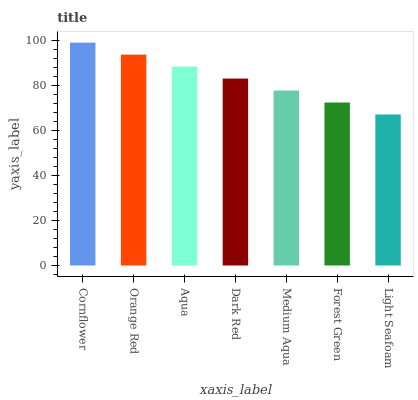Is Light Seafoam the minimum?
Answer yes or no. Yes. Is Cornflower the maximum?
Answer yes or no. Yes. Is Orange Red the minimum?
Answer yes or no. No. Is Orange Red the maximum?
Answer yes or no. No. Is Cornflower greater than Orange Red?
Answer yes or no. Yes. Is Orange Red less than Cornflower?
Answer yes or no. Yes. Is Orange Red greater than Cornflower?
Answer yes or no. No. Is Cornflower less than Orange Red?
Answer yes or no. No. Is Dark Red the high median?
Answer yes or no. Yes. Is Dark Red the low median?
Answer yes or no. Yes. Is Aqua the high median?
Answer yes or no. No. Is Light Seafoam the low median?
Answer yes or no. No. 